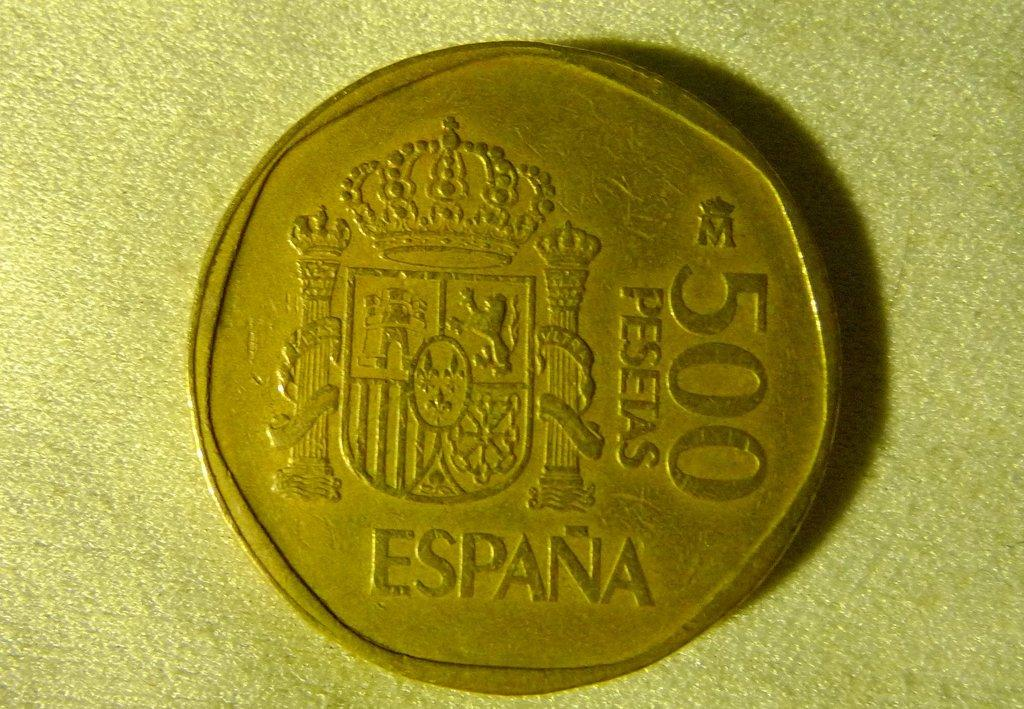<image>
Share a concise interpretation of the image provided. Copper coin which says the word "ESPANA" on it. 